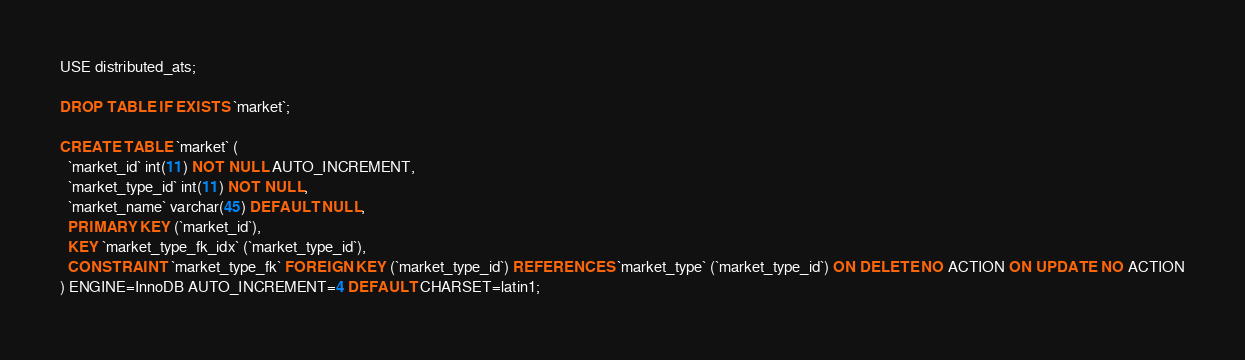Convert code to text. <code><loc_0><loc_0><loc_500><loc_500><_SQL_>USE distributed_ats;
  
DROP TABLE IF EXISTS `market`;

CREATE TABLE `market` (
  `market_id` int(11) NOT NULL AUTO_INCREMENT,
  `market_type_id` int(11) NOT NULL,
  `market_name` varchar(45) DEFAULT NULL,
  PRIMARY KEY (`market_id`),
  KEY `market_type_fk_idx` (`market_type_id`),
  CONSTRAINT `market_type_fk` FOREIGN KEY (`market_type_id`) REFERENCES `market_type` (`market_type_id`) ON DELETE NO ACTION ON UPDATE NO ACTION
) ENGINE=InnoDB AUTO_INCREMENT=4 DEFAULT CHARSET=latin1;
</code> 